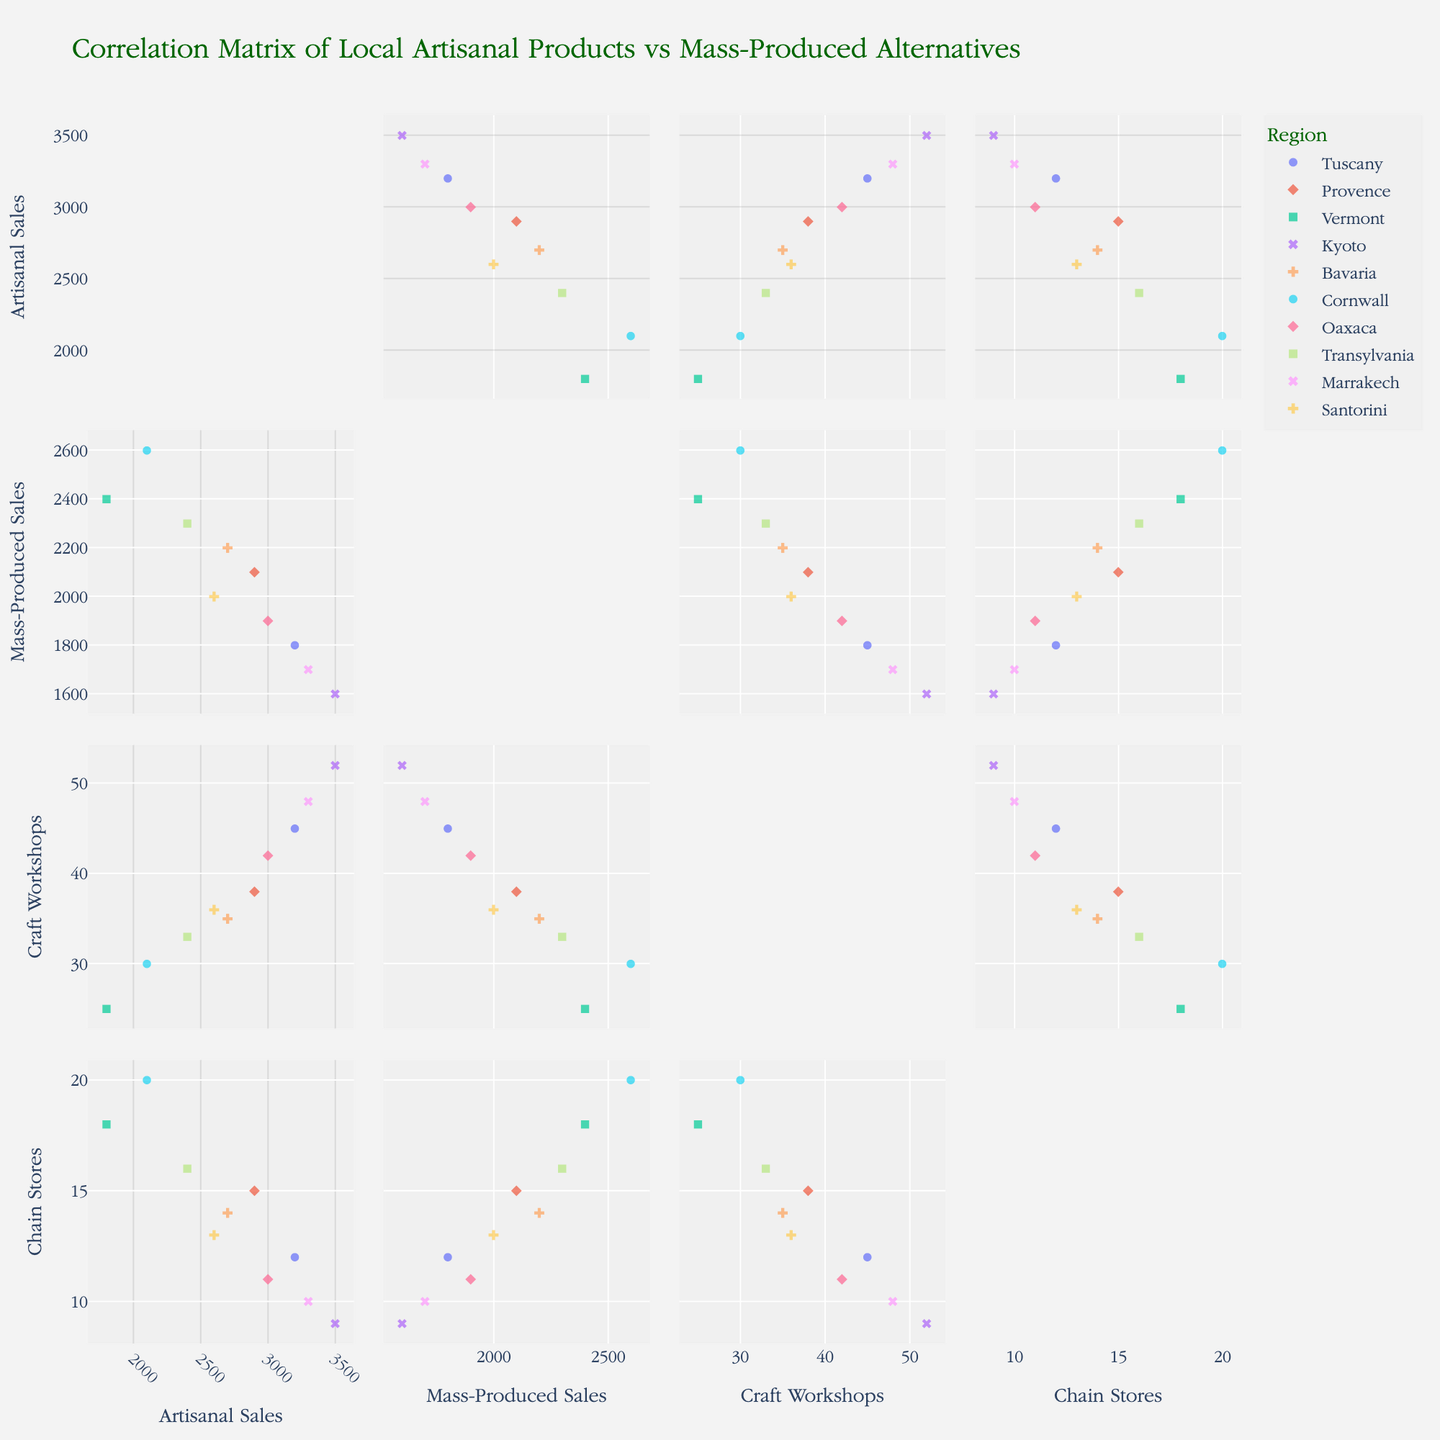What is the title of the figure? Look at the top of the figure to find the text that states its title.
Answer: Correlation Matrix of Local Artisanal Products vs Mass-Produced Alternatives Which region has the highest local artisanal sales? Scan the scatterplot matrix for the point representing the highest value on the Local_Artisanal_Sales axis. Identify the corresponding region based on the legend.
Answer: Kyoto What is the average number of traditional craft workshops across all regions? Sum the values of Traditional_Craft_Workshops for all regions and divide by the number of regions. (45+38+25+52+35+30+42+33+48+36)/10 = 38.4
Answer: 38.4 Is there a trend between mass-produced sales and the presence of chain stores? Examine the scatterplots comparing Mass_Produced_Sales to Chain_Store_Presence to see if more chain stores generally correlate with higher or lower mass-produced sales.
Answer: Positive trend How do local artisanal sales compare between Tuscany and Vermont? Find the points representing Tuscany and Vermont on the Local_Artisanal_Sales axis and compare their values. Tuscany has 3200, and Vermont has 1800.
Answer: Tuscany has higher sales than Vermont Which region has the lowest presence of chain stores? Identify the point with the lowest value on the Chain_Store_Presence axis and check the corresponding region using the legend.
Answer: Kyoto Do regions with more traditional craft workshops generally have higher local artisanal sales? Look at the scatterplot comparing Traditional_Craft_Workshops to Local_Artisanal_Sales to see if there is a positive correlation.
Answer: Yes Which region has a higher mass-produced sales, Provence or Marrakech? Compare the Mass_Produced_Sales values for Provence (2100) and Marrakech (1700).
Answer: Provence Is the range of local artisanal sales values greater than the range of mass-produced sales values? Calculate the range for each: Local_Artisanal_Sales range is 3500 - 1800 = 1700; Mass_Produced_Sales range is 2600 - 1600 = 1000. Compare the two ranges.
Answer: Yes How many regions have local artisanal sales over 3000? Count the number of points with Local_Artisanal_Sales above 3000. The regions are Tuscany, Kyoto, Oaxaca, and Marrakech.
Answer: 4 